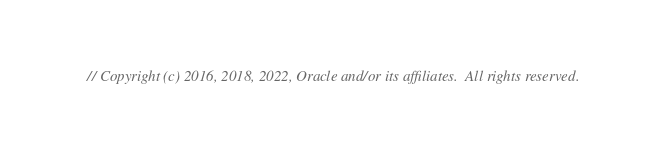Convert code to text. <code><loc_0><loc_0><loc_500><loc_500><_Go_>// Copyright (c) 2016, 2018, 2022, Oracle and/or its affiliates.  All rights reserved.</code> 